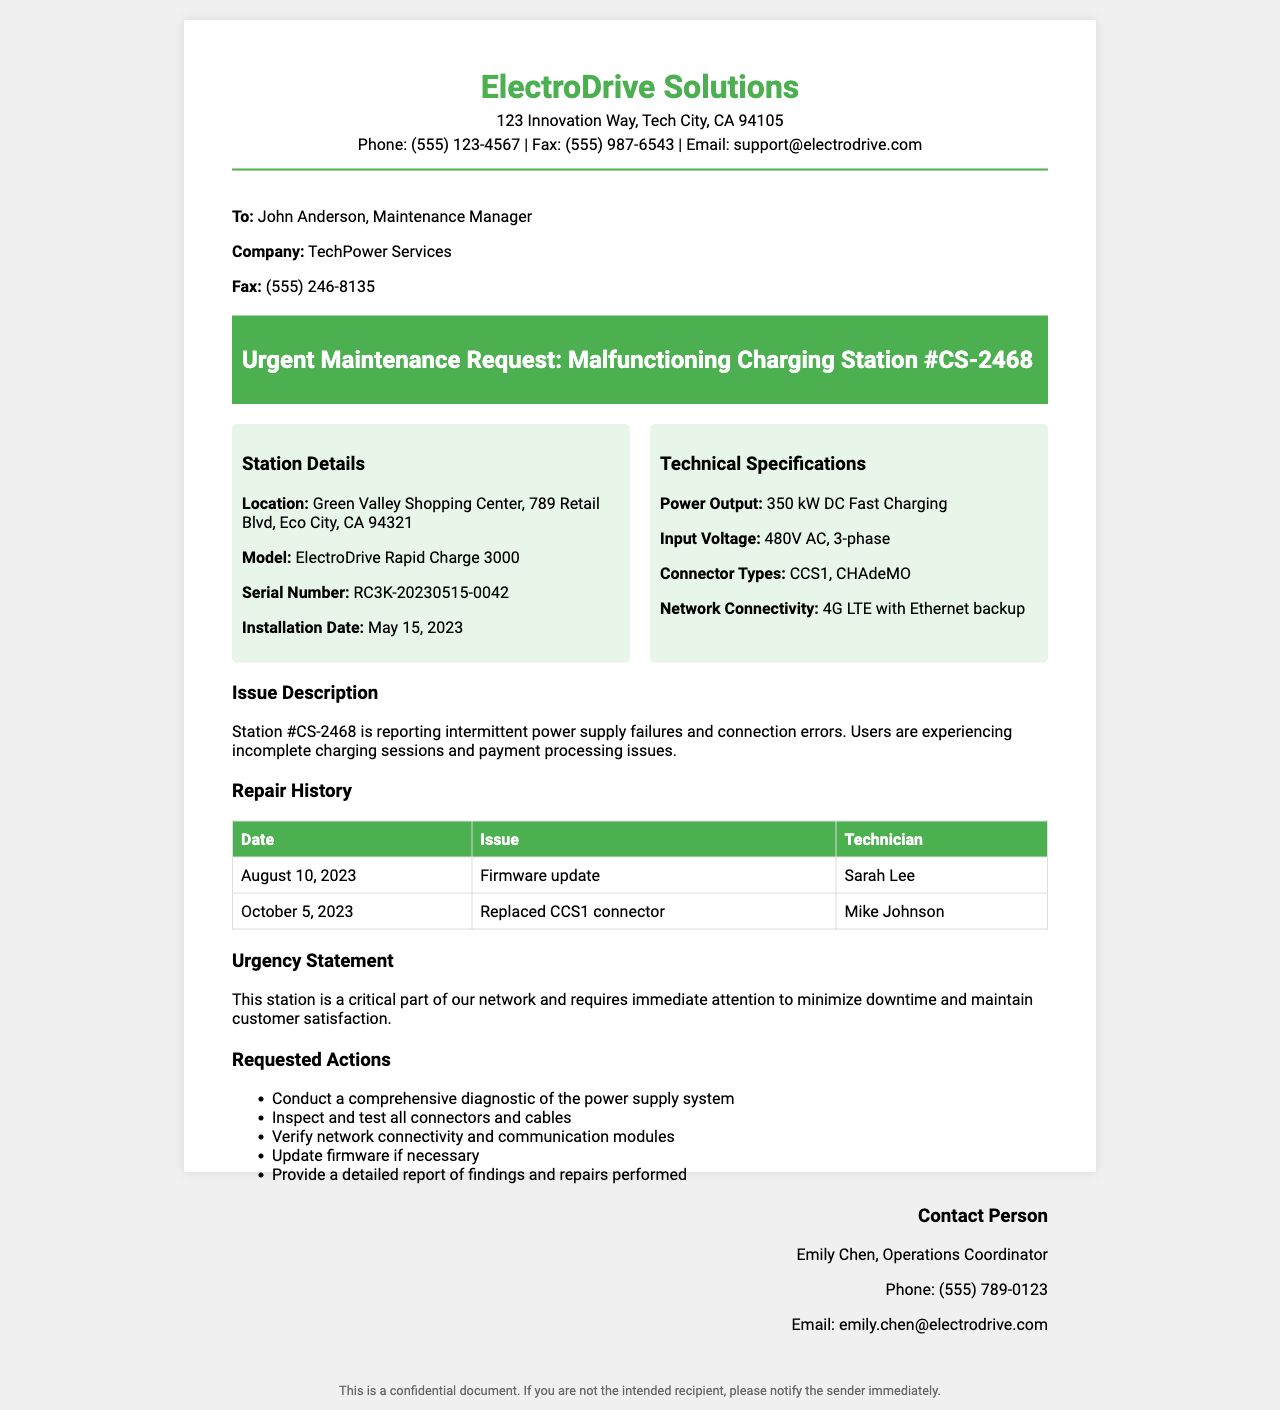what is the location of the charging station? The location is listed under "Station Details" in the document as Green Valley Shopping Center, 789 Retail Blvd, Eco City, CA 94321.
Answer: Green Valley Shopping Center, 789 Retail Blvd, Eco City, CA 94321 who is the maintenance manager? The maintenance manager is mentioned in the recipient section of the document.
Answer: John Anderson what is the model of the malfunctioning charging station? The model is specified in the station details section of the document.
Answer: ElectroDrive Rapid Charge 3000 when was the installation date of the charging station? The installation date is found in the "Station Details" section.
Answer: May 15, 2023 what issue is being reported for station #CS-2468? The issue description outlines the problem encountered by the charging station.
Answer: Intermittent power supply failures and connection errors how many actions are requested in the maintenance request? The number of requested actions can be counted from the actions section of the document.
Answer: Five who is the contact person for this maintenance request? The contact person is mentioned in the "Contact Person" section of the document.
Answer: Emily Chen what was the last maintenance action performed and on what date? The repair history section shows the most recent maintenance action taken and its date.
Answer: Replaced CCS1 connector on October 5, 2023 what is the urgency statement regarding the charging station? The urgency statement describes the importance of the station within the network.
Answer: This station is a critical part of our network and requires immediate attention to minimize downtime and maintain customer satisfaction 